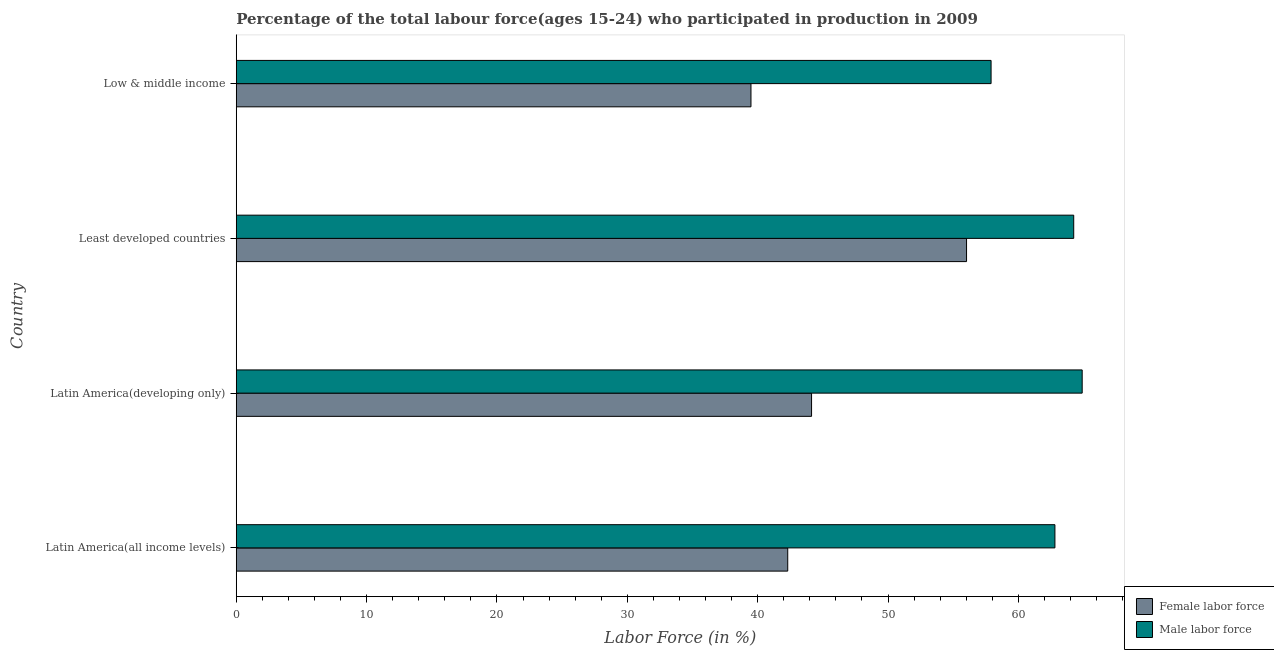Are the number of bars on each tick of the Y-axis equal?
Offer a terse response. Yes. How many bars are there on the 1st tick from the bottom?
Make the answer very short. 2. What is the label of the 2nd group of bars from the top?
Offer a terse response. Least developed countries. What is the percentage of female labor force in Latin America(all income levels)?
Your answer should be very brief. 42.31. Across all countries, what is the maximum percentage of male labour force?
Your answer should be very brief. 64.9. Across all countries, what is the minimum percentage of female labor force?
Provide a short and direct response. 39.49. In which country was the percentage of female labor force maximum?
Your answer should be compact. Least developed countries. What is the total percentage of male labour force in the graph?
Keep it short and to the point. 249.86. What is the difference between the percentage of male labour force in Latin America(all income levels) and that in Low & middle income?
Offer a very short reply. 4.9. What is the difference between the percentage of female labor force in Least developed countries and the percentage of male labour force in Latin America(all income levels)?
Offer a very short reply. -6.78. What is the average percentage of female labor force per country?
Your answer should be very brief. 45.49. What is the difference between the percentage of female labor force and percentage of male labour force in Low & middle income?
Provide a short and direct response. -18.42. In how many countries, is the percentage of male labour force greater than 20 %?
Provide a succinct answer. 4. Is the percentage of female labor force in Latin America(all income levels) less than that in Latin America(developing only)?
Your answer should be compact. Yes. What is the difference between the highest and the second highest percentage of male labour force?
Your answer should be very brief. 0.65. What is the difference between the highest and the lowest percentage of female labor force?
Offer a very short reply. 16.54. In how many countries, is the percentage of female labor force greater than the average percentage of female labor force taken over all countries?
Provide a short and direct response. 1. Is the sum of the percentage of female labor force in Latin America(all income levels) and Low & middle income greater than the maximum percentage of male labour force across all countries?
Give a very brief answer. Yes. What does the 2nd bar from the top in Low & middle income represents?
Your answer should be compact. Female labor force. What does the 2nd bar from the bottom in Latin America(all income levels) represents?
Offer a very short reply. Male labor force. How many bars are there?
Your response must be concise. 8. Are all the bars in the graph horizontal?
Provide a succinct answer. Yes. How many countries are there in the graph?
Ensure brevity in your answer.  4. Are the values on the major ticks of X-axis written in scientific E-notation?
Provide a short and direct response. No. Does the graph contain any zero values?
Your response must be concise. No. What is the title of the graph?
Give a very brief answer. Percentage of the total labour force(ages 15-24) who participated in production in 2009. Does "Secondary" appear as one of the legend labels in the graph?
Your answer should be compact. No. What is the label or title of the X-axis?
Offer a terse response. Labor Force (in %). What is the label or title of the Y-axis?
Your response must be concise. Country. What is the Labor Force (in %) of Female labor force in Latin America(all income levels)?
Your response must be concise. 42.31. What is the Labor Force (in %) of Male labor force in Latin America(all income levels)?
Offer a very short reply. 62.81. What is the Labor Force (in %) of Female labor force in Latin America(developing only)?
Keep it short and to the point. 44.14. What is the Labor Force (in %) in Male labor force in Latin America(developing only)?
Provide a short and direct response. 64.9. What is the Labor Force (in %) in Female labor force in Least developed countries?
Make the answer very short. 56.03. What is the Labor Force (in %) in Male labor force in Least developed countries?
Ensure brevity in your answer.  64.25. What is the Labor Force (in %) in Female labor force in Low & middle income?
Offer a very short reply. 39.49. What is the Labor Force (in %) in Male labor force in Low & middle income?
Make the answer very short. 57.91. Across all countries, what is the maximum Labor Force (in %) of Female labor force?
Provide a succinct answer. 56.03. Across all countries, what is the maximum Labor Force (in %) of Male labor force?
Give a very brief answer. 64.9. Across all countries, what is the minimum Labor Force (in %) in Female labor force?
Give a very brief answer. 39.49. Across all countries, what is the minimum Labor Force (in %) in Male labor force?
Your answer should be compact. 57.91. What is the total Labor Force (in %) of Female labor force in the graph?
Give a very brief answer. 181.96. What is the total Labor Force (in %) of Male labor force in the graph?
Offer a terse response. 249.86. What is the difference between the Labor Force (in %) in Female labor force in Latin America(all income levels) and that in Latin America(developing only)?
Make the answer very short. -1.83. What is the difference between the Labor Force (in %) in Male labor force in Latin America(all income levels) and that in Latin America(developing only)?
Give a very brief answer. -2.09. What is the difference between the Labor Force (in %) in Female labor force in Latin America(all income levels) and that in Least developed countries?
Offer a very short reply. -13.72. What is the difference between the Labor Force (in %) in Male labor force in Latin America(all income levels) and that in Least developed countries?
Keep it short and to the point. -1.44. What is the difference between the Labor Force (in %) of Female labor force in Latin America(all income levels) and that in Low & middle income?
Provide a succinct answer. 2.82. What is the difference between the Labor Force (in %) in Male labor force in Latin America(all income levels) and that in Low & middle income?
Your answer should be very brief. 4.9. What is the difference between the Labor Force (in %) in Female labor force in Latin America(developing only) and that in Least developed countries?
Your answer should be very brief. -11.89. What is the difference between the Labor Force (in %) in Male labor force in Latin America(developing only) and that in Least developed countries?
Give a very brief answer. 0.65. What is the difference between the Labor Force (in %) in Female labor force in Latin America(developing only) and that in Low & middle income?
Offer a very short reply. 4.65. What is the difference between the Labor Force (in %) of Male labor force in Latin America(developing only) and that in Low & middle income?
Make the answer very short. 6.99. What is the difference between the Labor Force (in %) in Female labor force in Least developed countries and that in Low & middle income?
Offer a very short reply. 16.54. What is the difference between the Labor Force (in %) in Male labor force in Least developed countries and that in Low & middle income?
Your answer should be very brief. 6.34. What is the difference between the Labor Force (in %) in Female labor force in Latin America(all income levels) and the Labor Force (in %) in Male labor force in Latin America(developing only)?
Keep it short and to the point. -22.59. What is the difference between the Labor Force (in %) of Female labor force in Latin America(all income levels) and the Labor Force (in %) of Male labor force in Least developed countries?
Provide a short and direct response. -21.94. What is the difference between the Labor Force (in %) of Female labor force in Latin America(all income levels) and the Labor Force (in %) of Male labor force in Low & middle income?
Your response must be concise. -15.6. What is the difference between the Labor Force (in %) in Female labor force in Latin America(developing only) and the Labor Force (in %) in Male labor force in Least developed countries?
Offer a terse response. -20.11. What is the difference between the Labor Force (in %) of Female labor force in Latin America(developing only) and the Labor Force (in %) of Male labor force in Low & middle income?
Your answer should be very brief. -13.77. What is the difference between the Labor Force (in %) of Female labor force in Least developed countries and the Labor Force (in %) of Male labor force in Low & middle income?
Provide a short and direct response. -1.88. What is the average Labor Force (in %) in Female labor force per country?
Make the answer very short. 45.49. What is the average Labor Force (in %) of Male labor force per country?
Give a very brief answer. 62.46. What is the difference between the Labor Force (in %) of Female labor force and Labor Force (in %) of Male labor force in Latin America(all income levels)?
Your answer should be very brief. -20.5. What is the difference between the Labor Force (in %) of Female labor force and Labor Force (in %) of Male labor force in Latin America(developing only)?
Make the answer very short. -20.76. What is the difference between the Labor Force (in %) of Female labor force and Labor Force (in %) of Male labor force in Least developed countries?
Make the answer very short. -8.22. What is the difference between the Labor Force (in %) of Female labor force and Labor Force (in %) of Male labor force in Low & middle income?
Provide a short and direct response. -18.42. What is the ratio of the Labor Force (in %) of Female labor force in Latin America(all income levels) to that in Latin America(developing only)?
Your answer should be compact. 0.96. What is the ratio of the Labor Force (in %) of Male labor force in Latin America(all income levels) to that in Latin America(developing only)?
Keep it short and to the point. 0.97. What is the ratio of the Labor Force (in %) of Female labor force in Latin America(all income levels) to that in Least developed countries?
Make the answer very short. 0.76. What is the ratio of the Labor Force (in %) of Male labor force in Latin America(all income levels) to that in Least developed countries?
Provide a succinct answer. 0.98. What is the ratio of the Labor Force (in %) in Female labor force in Latin America(all income levels) to that in Low & middle income?
Offer a terse response. 1.07. What is the ratio of the Labor Force (in %) in Male labor force in Latin America(all income levels) to that in Low & middle income?
Your response must be concise. 1.08. What is the ratio of the Labor Force (in %) of Female labor force in Latin America(developing only) to that in Least developed countries?
Your answer should be very brief. 0.79. What is the ratio of the Labor Force (in %) of Male labor force in Latin America(developing only) to that in Least developed countries?
Give a very brief answer. 1.01. What is the ratio of the Labor Force (in %) in Female labor force in Latin America(developing only) to that in Low & middle income?
Offer a very short reply. 1.12. What is the ratio of the Labor Force (in %) in Male labor force in Latin America(developing only) to that in Low & middle income?
Offer a very short reply. 1.12. What is the ratio of the Labor Force (in %) of Female labor force in Least developed countries to that in Low & middle income?
Your answer should be compact. 1.42. What is the ratio of the Labor Force (in %) of Male labor force in Least developed countries to that in Low & middle income?
Ensure brevity in your answer.  1.11. What is the difference between the highest and the second highest Labor Force (in %) of Female labor force?
Offer a very short reply. 11.89. What is the difference between the highest and the second highest Labor Force (in %) in Male labor force?
Ensure brevity in your answer.  0.65. What is the difference between the highest and the lowest Labor Force (in %) of Female labor force?
Your answer should be very brief. 16.54. What is the difference between the highest and the lowest Labor Force (in %) in Male labor force?
Ensure brevity in your answer.  6.99. 